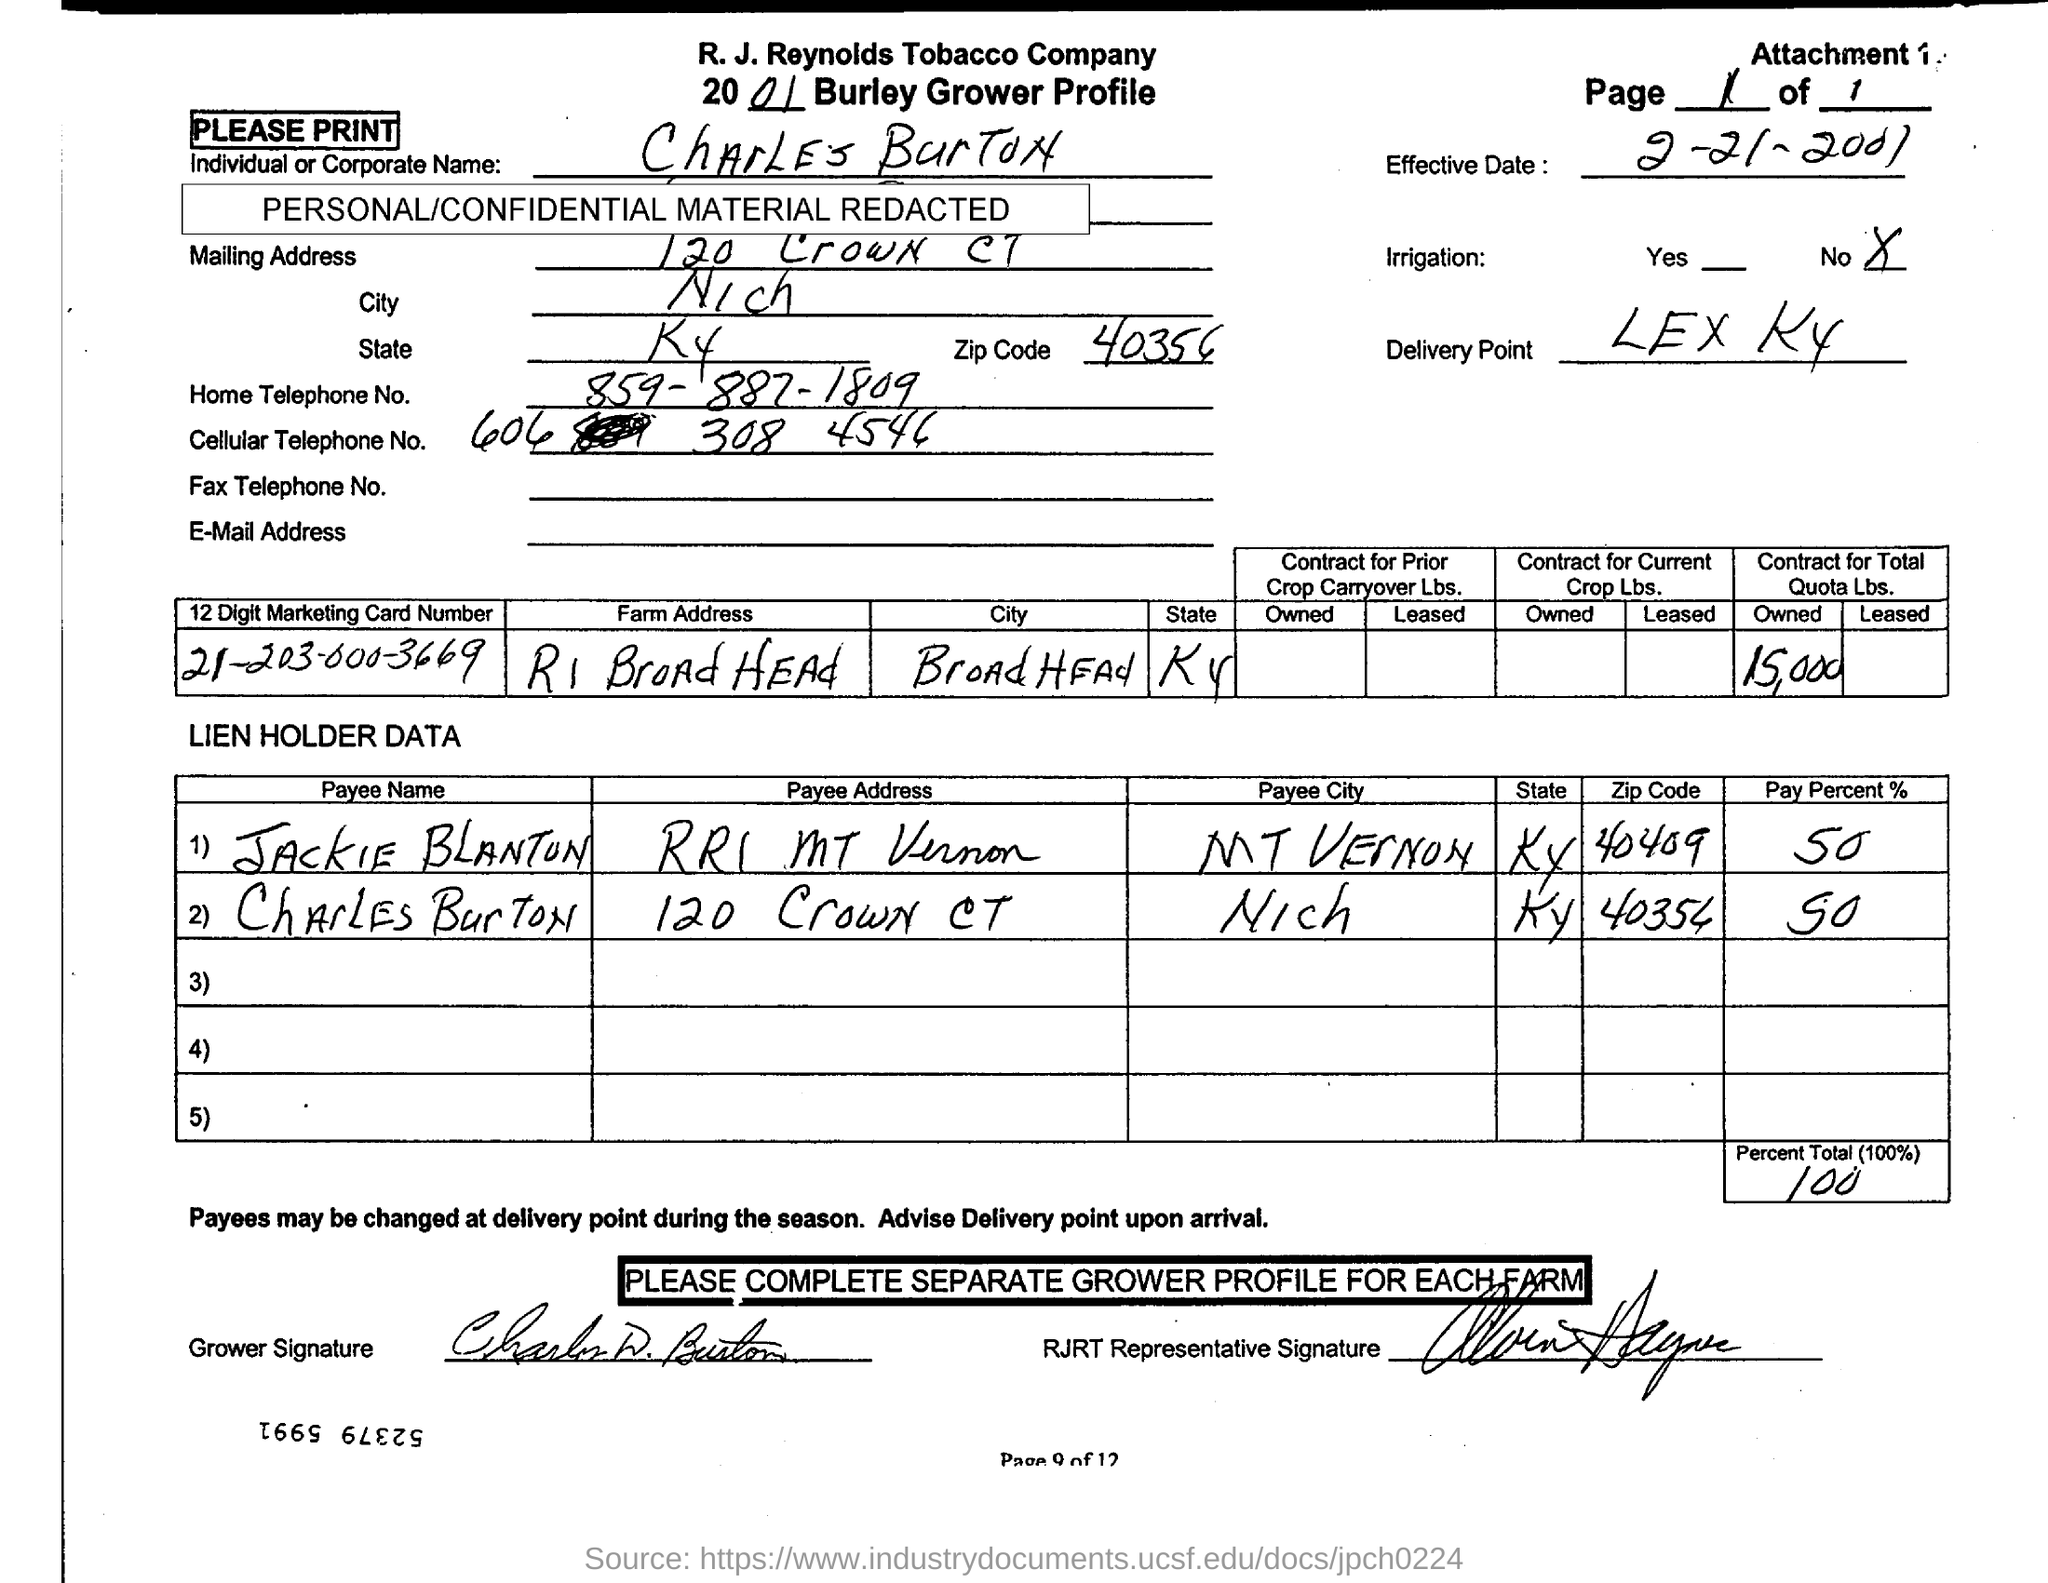What percentage of the payment is Jack Blanton responsible for? Jack Blanton is responsible for 50% of the payment, as listed under the 'Pay Percent' section beside his name. And the other 50%? The remaining 50% of the payment is the responsibility of Charles Burton, whose name also appears in the lien holder data with the specified pay percent. 